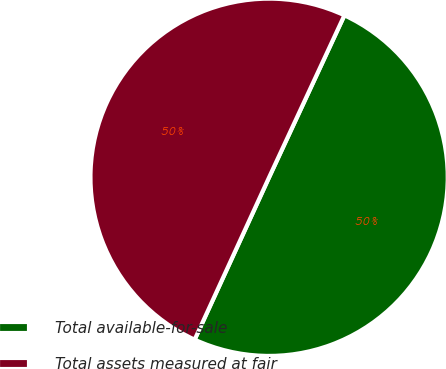Convert chart to OTSL. <chart><loc_0><loc_0><loc_500><loc_500><pie_chart><fcel>Total available-for-sale<fcel>Total assets measured at fair<nl><fcel>49.92%<fcel>50.08%<nl></chart> 